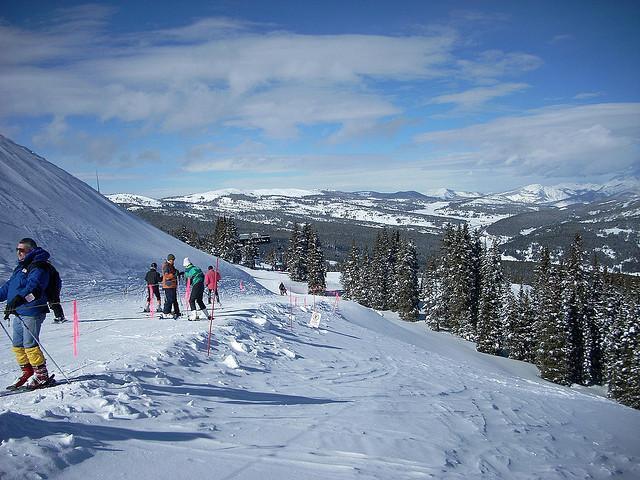How many miniature horses are there in the field?
Give a very brief answer. 0. 